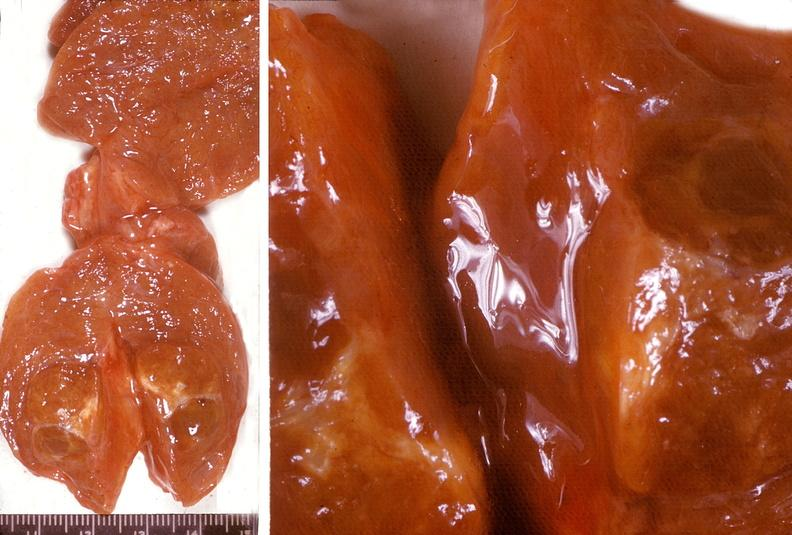s endocrine present?
Answer the question using a single word or phrase. Yes 